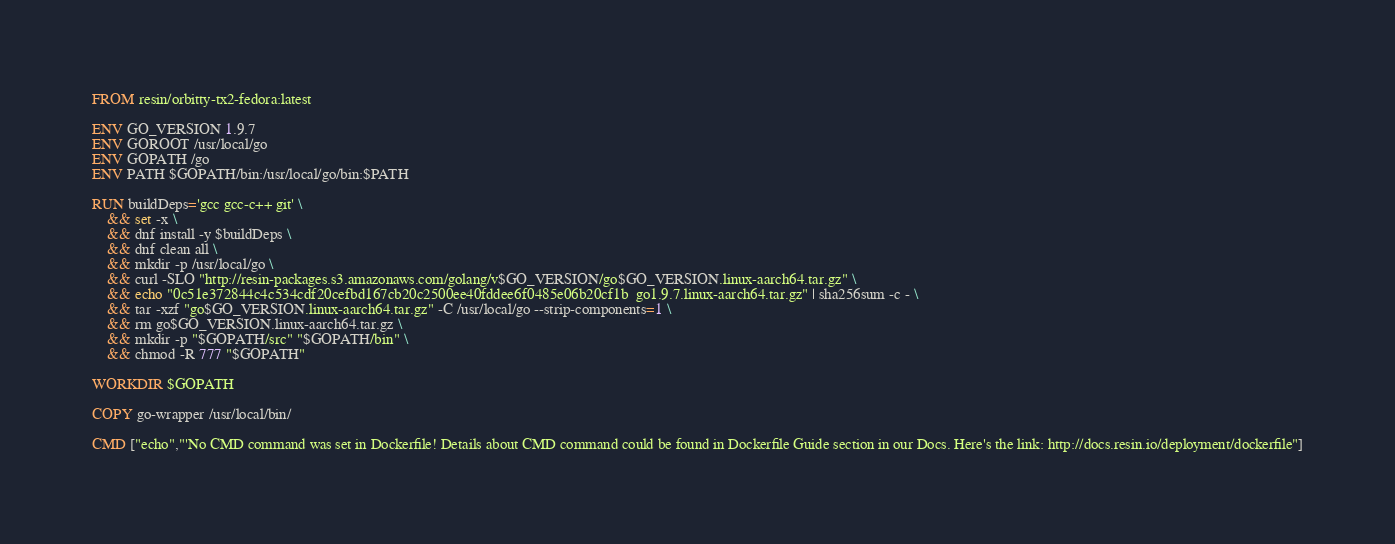<code> <loc_0><loc_0><loc_500><loc_500><_Dockerfile_>FROM resin/orbitty-tx2-fedora:latest

ENV GO_VERSION 1.9.7
ENV GOROOT /usr/local/go
ENV GOPATH /go
ENV PATH $GOPATH/bin:/usr/local/go/bin:$PATH

RUN buildDeps='gcc gcc-c++ git' \
	&& set -x \
	&& dnf install -y $buildDeps \
	&& dnf clean all \
	&& mkdir -p /usr/local/go \
	&& curl -SLO "http://resin-packages.s3.amazonaws.com/golang/v$GO_VERSION/go$GO_VERSION.linux-aarch64.tar.gz" \
	&& echo "0c51e372844c4c534cdf20cefbd167cb20c2500ee40fddee6f0485e06b20cf1b  go1.9.7.linux-aarch64.tar.gz" | sha256sum -c - \
	&& tar -xzf "go$GO_VERSION.linux-aarch64.tar.gz" -C /usr/local/go --strip-components=1 \
	&& rm go$GO_VERSION.linux-aarch64.tar.gz \
	&& mkdir -p "$GOPATH/src" "$GOPATH/bin" \
	&& chmod -R 777 "$GOPATH"

WORKDIR $GOPATH

COPY go-wrapper /usr/local/bin/

CMD ["echo","'No CMD command was set in Dockerfile! Details about CMD command could be found in Dockerfile Guide section in our Docs. Here's the link: http://docs.resin.io/deployment/dockerfile"]
</code> 